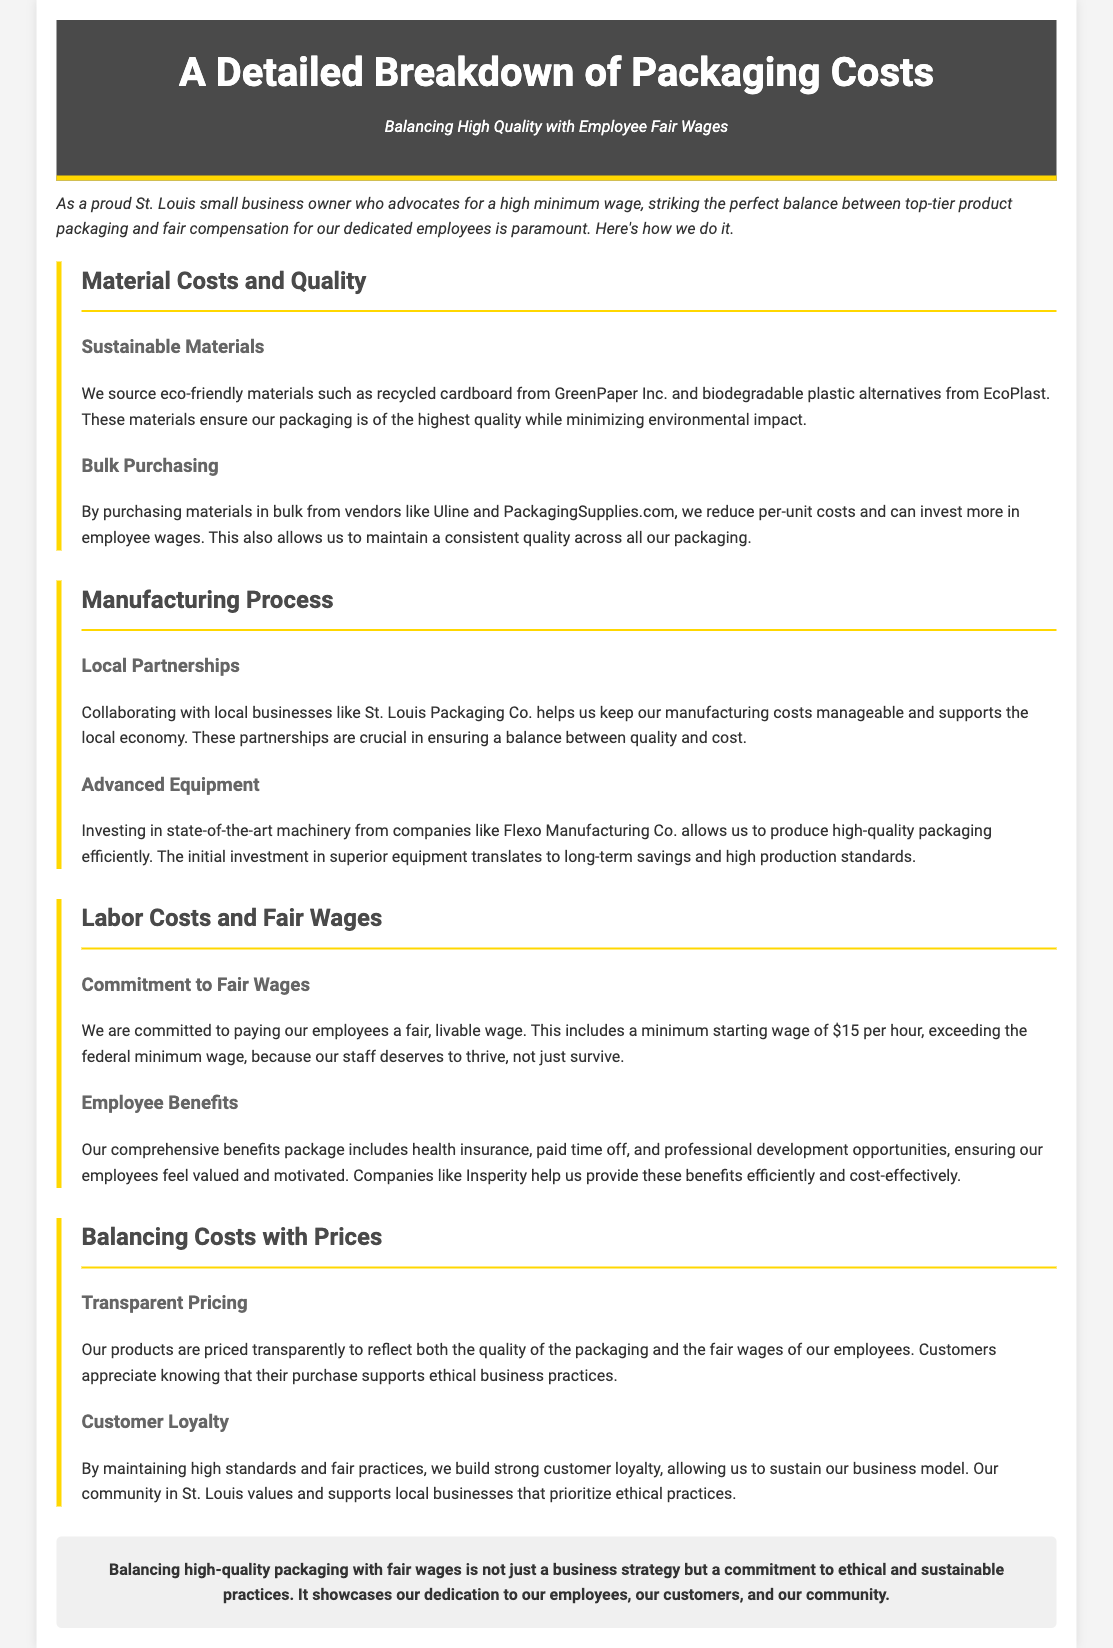what is the starting minimum wage? The document states that the minimum starting wage for employees is $15 per hour.
Answer: $15 per hour who do we source eco-friendly materials from? The document mentions sourcing eco-friendly materials from GreenPaper Inc. and EcoPlast.
Answer: GreenPaper Inc. and EcoPlast how does bulk purchasing help? Bulk purchasing reduces per-unit costs and allows for investment in employee wages while maintaining quality.
Answer: Reduces per-unit costs what is the benefit of local partnerships? Collaborating with local businesses helps keep manufacturing costs manageable and supports the local economy.
Answer: Supports the local economy what type of insurance is included in the benefits package? The comprehensive benefits package includes health insurance for employees.
Answer: Health insurance how does the document categorize the approach to pricing? The document describes the pricing approach as transparent to reflect quality and fair wages.
Answer: Transparent pricing which company assists in providing employee benefits? Insperity is mentioned as a company that helps provide employee benefits efficiently.
Answer: Insperity what is the overall commitment outlined in the conclusion? The conclusion emphasizes a commitment to ethical and sustainable practices.
Answer: Ethical and sustainable practices 